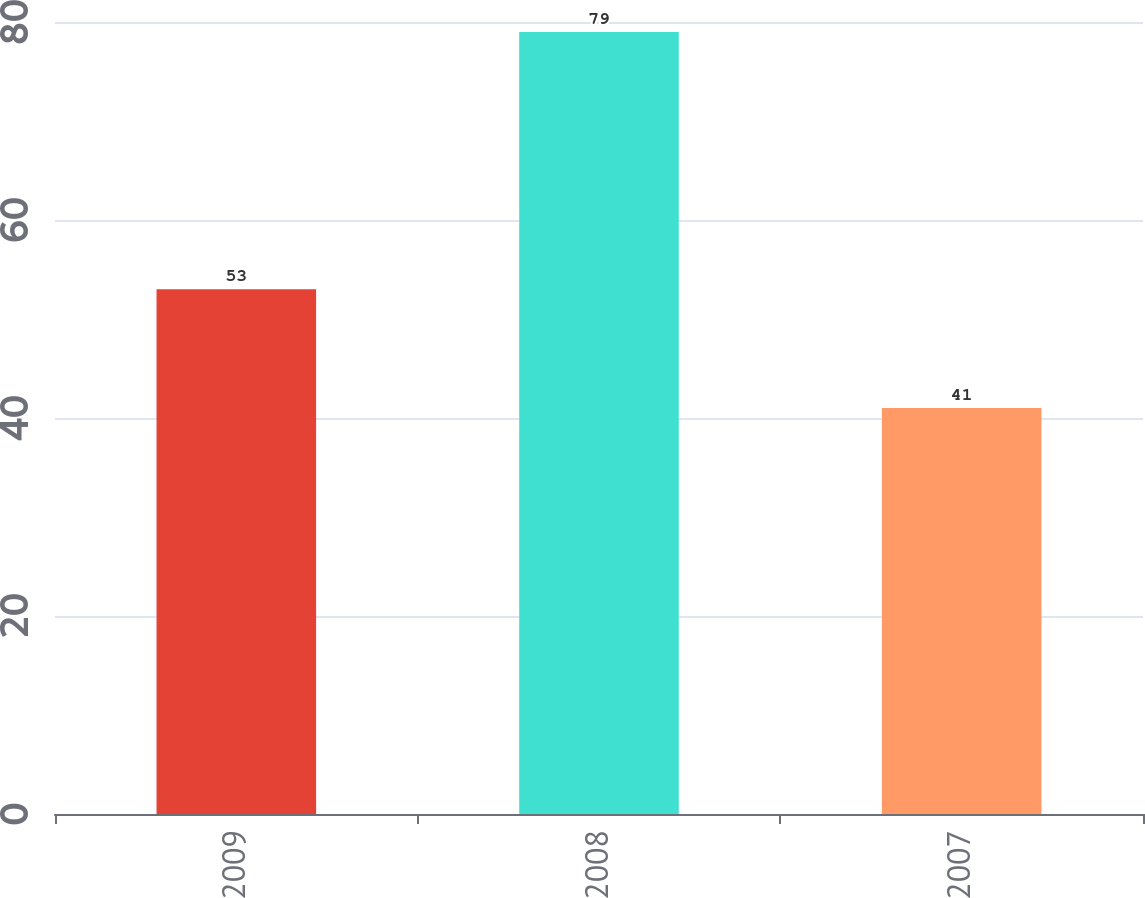Convert chart to OTSL. <chart><loc_0><loc_0><loc_500><loc_500><bar_chart><fcel>2009<fcel>2008<fcel>2007<nl><fcel>53<fcel>79<fcel>41<nl></chart> 